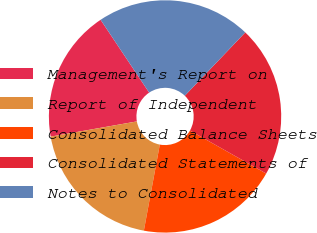<chart> <loc_0><loc_0><loc_500><loc_500><pie_chart><fcel>Management's Report on<fcel>Report of Independent<fcel>Consolidated Balance Sheets<fcel>Consolidated Statements of<fcel>Notes to Consolidated<nl><fcel>18.42%<fcel>19.3%<fcel>19.74%<fcel>21.05%<fcel>21.49%<nl></chart> 